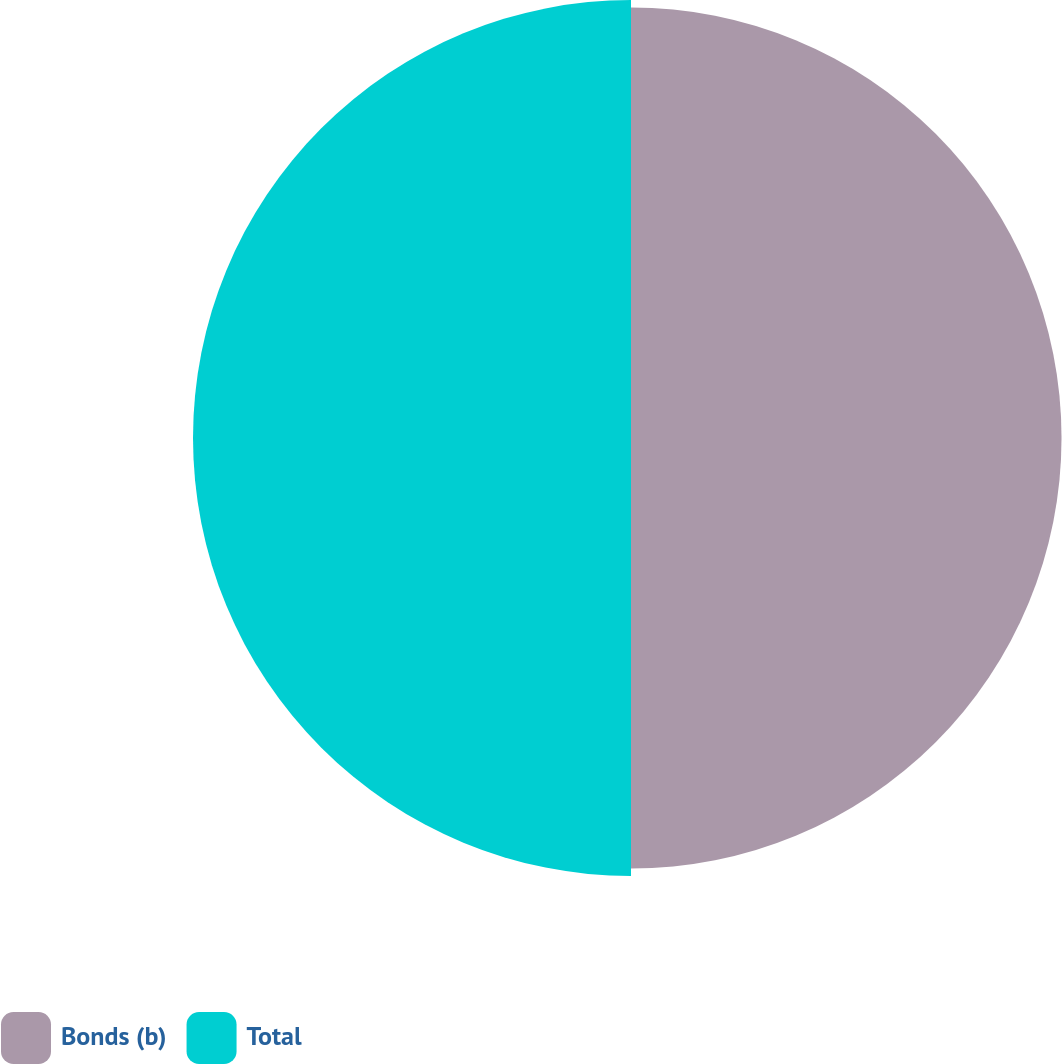<chart> <loc_0><loc_0><loc_500><loc_500><pie_chart><fcel>Bonds (b)<fcel>Total<nl><fcel>49.57%<fcel>50.43%<nl></chart> 